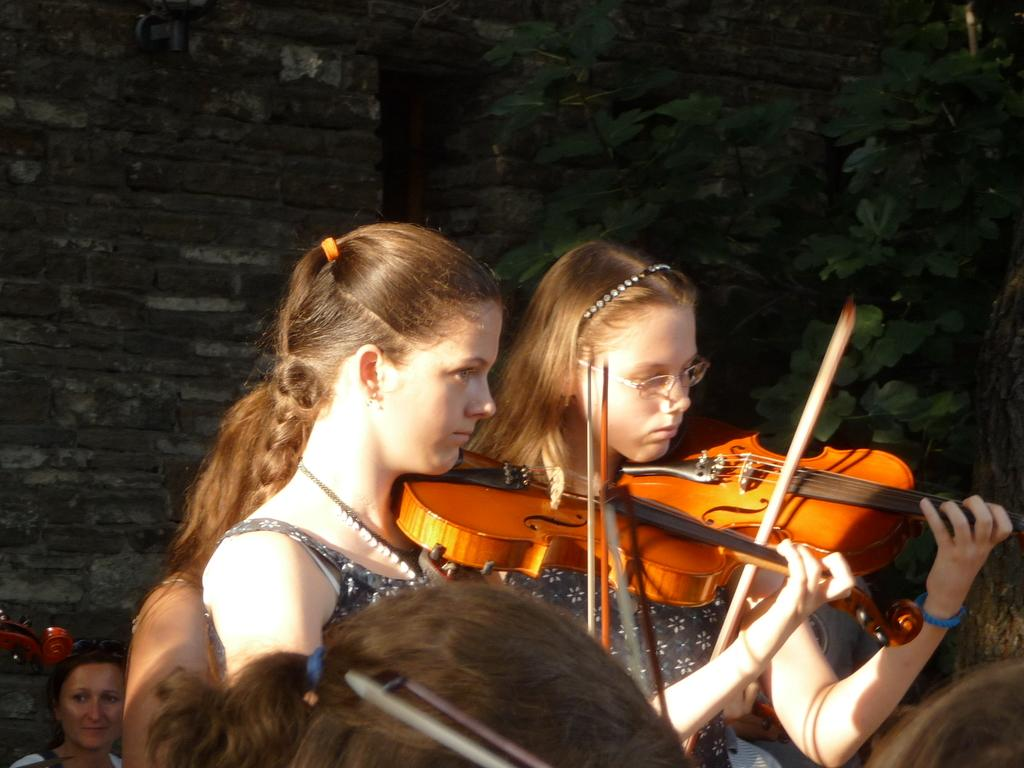How many people are in the image? There are two women in the image. What are the women doing in the image? The women are playing violins. What can be seen in the background of the image? There is a wall and a plant in the background of the image. What type of jewel is hanging from the board in the image? There is no board or jewel present in the image. 